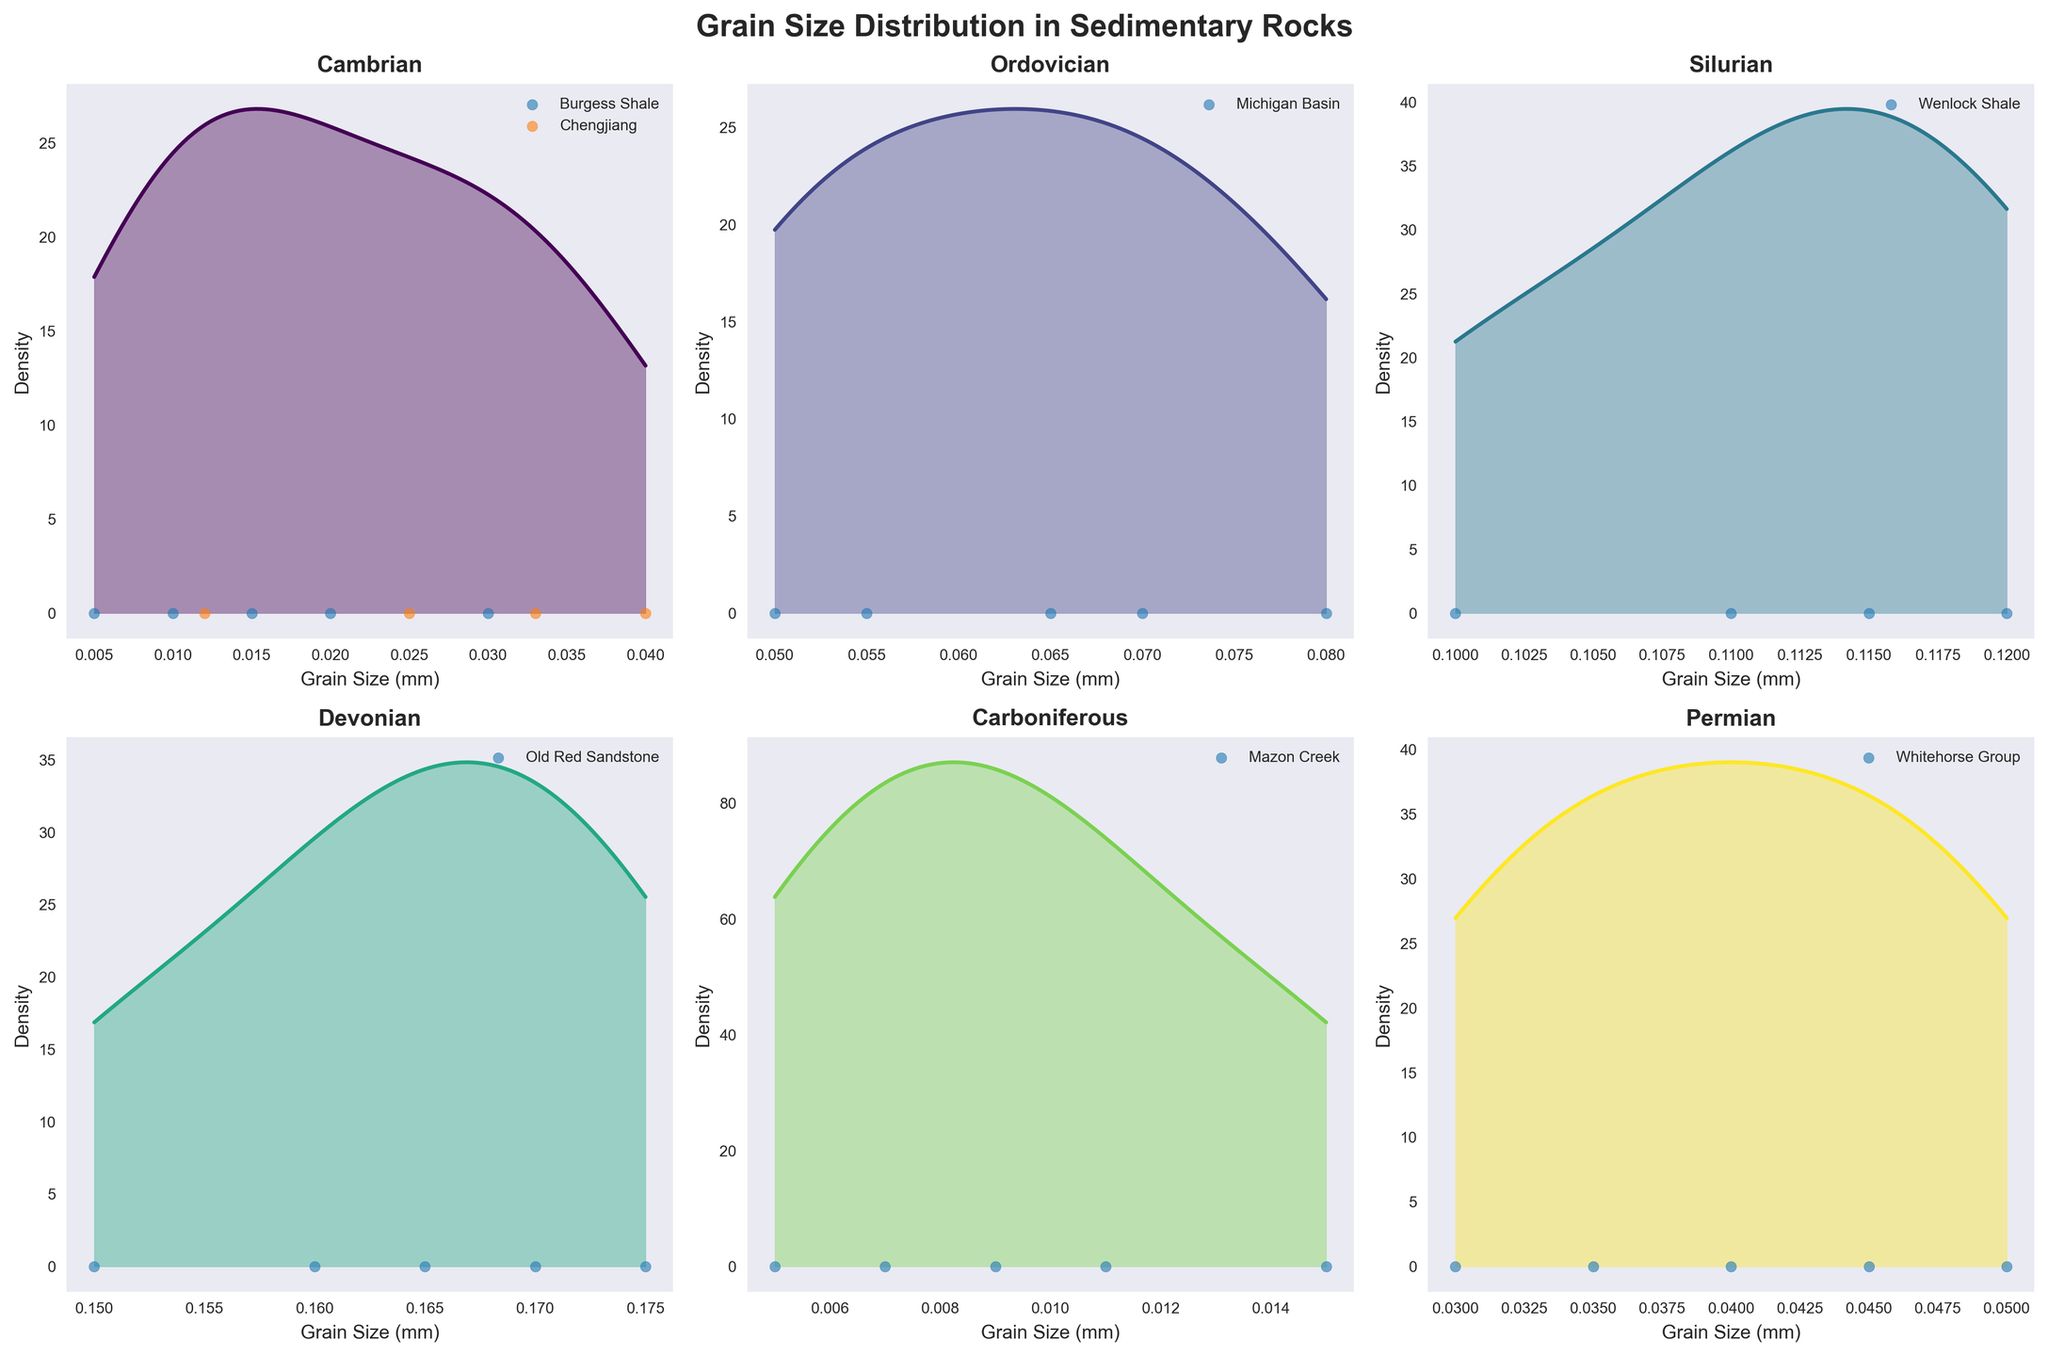What is the title of the figure? The title is usually displayed at the top of the figure and summarizes its content.
Answer: Grain Size Distribution in Sedimentary Rocks Which geological period has the broadest range of grain sizes? To determine this, look for the period subplot where the kernel density estimate (KDE) covers the largest span on the x-axis.
Answer: Devonian How many geological periods are included in the figure? Count the number of subplots, as each subplot represents a different geological period.
Answer: Six Which location has the highest concentration of grain sizes in the Cambrian period? Identify the location within the Cambrian period subplot (labeled with the highest density) by observing the KDE peaks and the labeled scatter plot points.
Answer: Chengjiang In which period does the Wenlock Shale location appear? Identify the period by examining the labels for the locations plotted within each period’s subplot.
Answer: Silurian Which geological period has the smallest grain sizes on average? Estimate the central tendency of the KDE plots across each period and compare their locations on the x-axis to find the smallest average grain size.
Answer: Cambrian Are grain sizes in the Ordovician period more varied compared to the Permian period? Compare the width of the KDE plots in the Ordovician and Permian period subplots to assess the variability in grain sizes.
Answer: Yes Which period exhibits the highest density peak in its KDE plot? Identify the highest point across all KDE plots within each subplot, representing the highest density of grain sizes.
Answer: Ordovician How do grain sizes in the Mazon Creek location compare to those in the Old Red Sandstone location? Compare the KDE plots and scatter plot points in the subplots for the Carboniferous and Devonian periods respectively, checking for differences in x-axis positions and spreads.
Answer: Mazon Creek has smaller grain sizes overall What is the typical grain size range for the Whitehorse Group in the Permian period? Refer to the Permian period subplot and observe the KDE plot's spread along the x-axis, supplemented by the scatter plot points for the Whitehorse Group.
Answer: 0.030 mm to 0.050 mm 